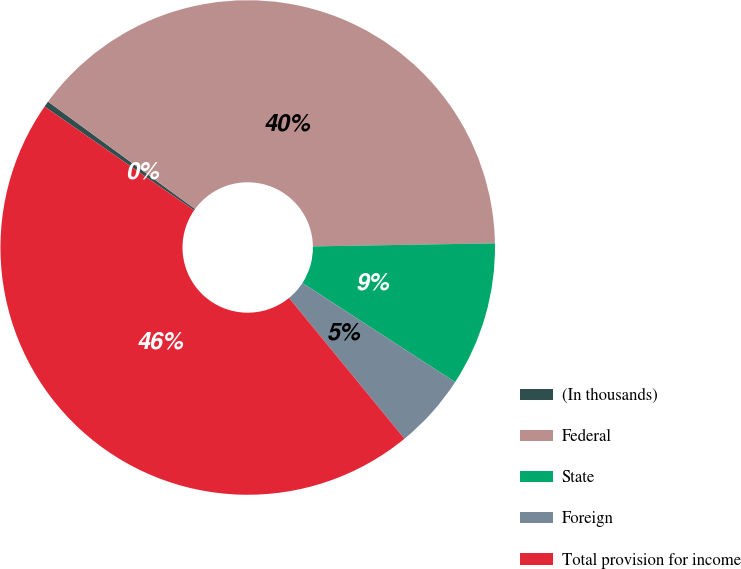Convert chart. <chart><loc_0><loc_0><loc_500><loc_500><pie_chart><fcel>(In thousands)<fcel>Federal<fcel>State<fcel>Foreign<fcel>Total provision for income<nl><fcel>0.39%<fcel>39.69%<fcel>9.43%<fcel>4.91%<fcel>45.58%<nl></chart> 